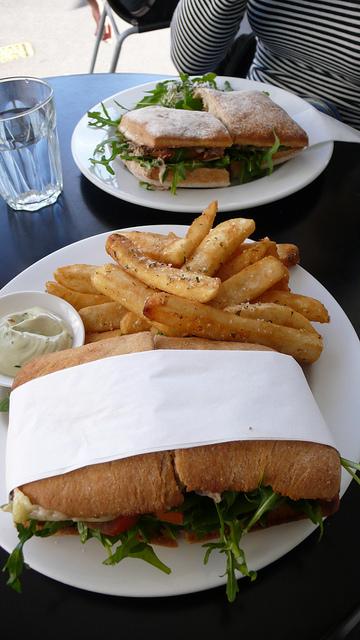What is next to the sandwich on the plate closest to the camera?
Write a very short answer. Fries. Is there a glass on the table?
Short answer required. Yes. Is this a homemade meal?
Quick response, please. No. 